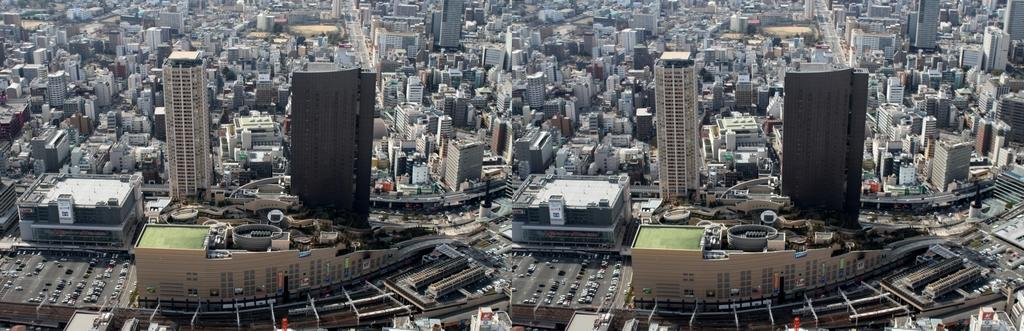What type of pictures are included in the image? The image contains collage pictures. What do the collage pictures depict? The collage pictures show aerial views of cities. What structures can be seen in the collage pictures? Buildings are visible in the collage pictures. What else can be seen in the collage pictures besides buildings? Vehicles, trees, and light poles are present in the collage pictures. Can you tell me how many partners are visible in the image? There are no partners present in the image; it contains collage pictures of aerial views of cities. 